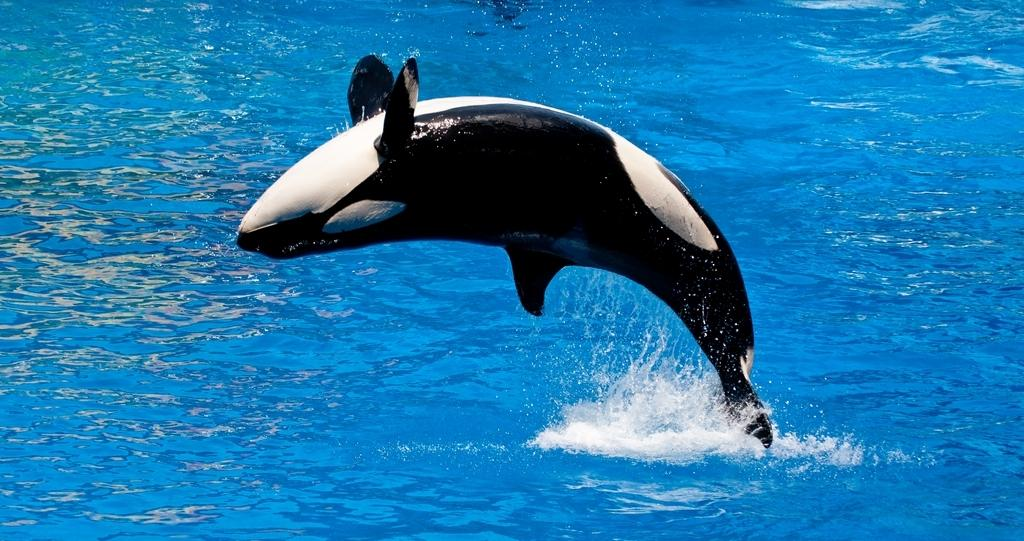What animal is present in the image? There is a dolphin in the image. What is the primary element in which the dolphin is situated? There is water visible in the image, and the dolphin is in the water. What type of crown is the queen wearing in the image? There is no queen or crown present in the image; it features a dolphin in water. Can you tell me how many kitties are playing with the dolphin in the image? There are no kitties present in the image; it features a dolphin in water. 